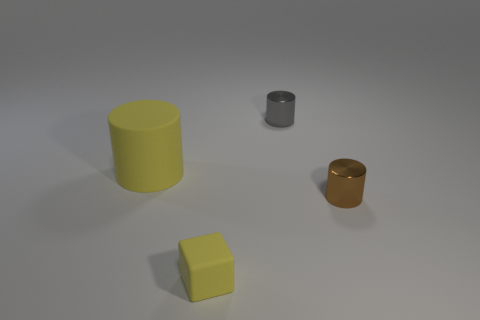Is the number of small yellow matte objects on the right side of the yellow rubber cube greater than the number of brown cylinders that are behind the tiny gray metallic thing?
Make the answer very short. No. What material is the object that is the same color as the tiny cube?
Provide a short and direct response. Rubber. What number of big objects are the same color as the matte block?
Your response must be concise. 1. There is a matte object that is in front of the large yellow cylinder; does it have the same color as the tiny metallic thing that is behind the brown cylinder?
Your response must be concise. No. Are there any big rubber objects behind the large thing?
Your answer should be very brief. No. What is the material of the big yellow cylinder?
Your answer should be very brief. Rubber. There is a tiny metal thing behind the yellow cylinder; what shape is it?
Your answer should be compact. Cylinder. What size is the thing that is the same color as the rubber block?
Make the answer very short. Large. Are there any shiny cylinders that have the same size as the block?
Ensure brevity in your answer.  Yes. Is the material of the tiny cylinder in front of the gray metal thing the same as the small yellow block?
Your answer should be compact. No. 